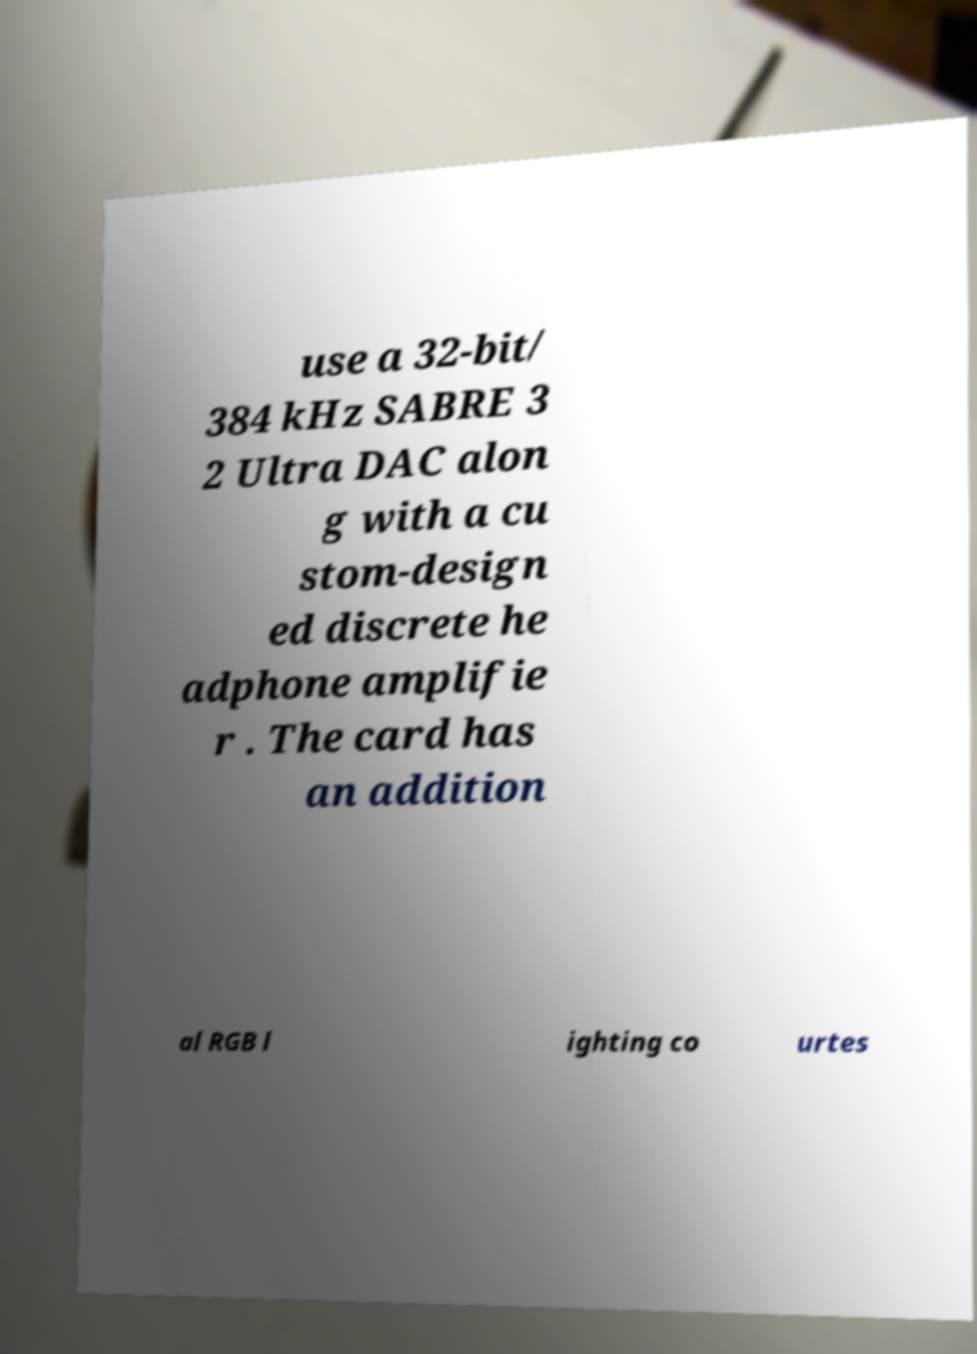Could you extract and type out the text from this image? use a 32-bit/ 384 kHz SABRE 3 2 Ultra DAC alon g with a cu stom-design ed discrete he adphone amplifie r . The card has an addition al RGB l ighting co urtes 